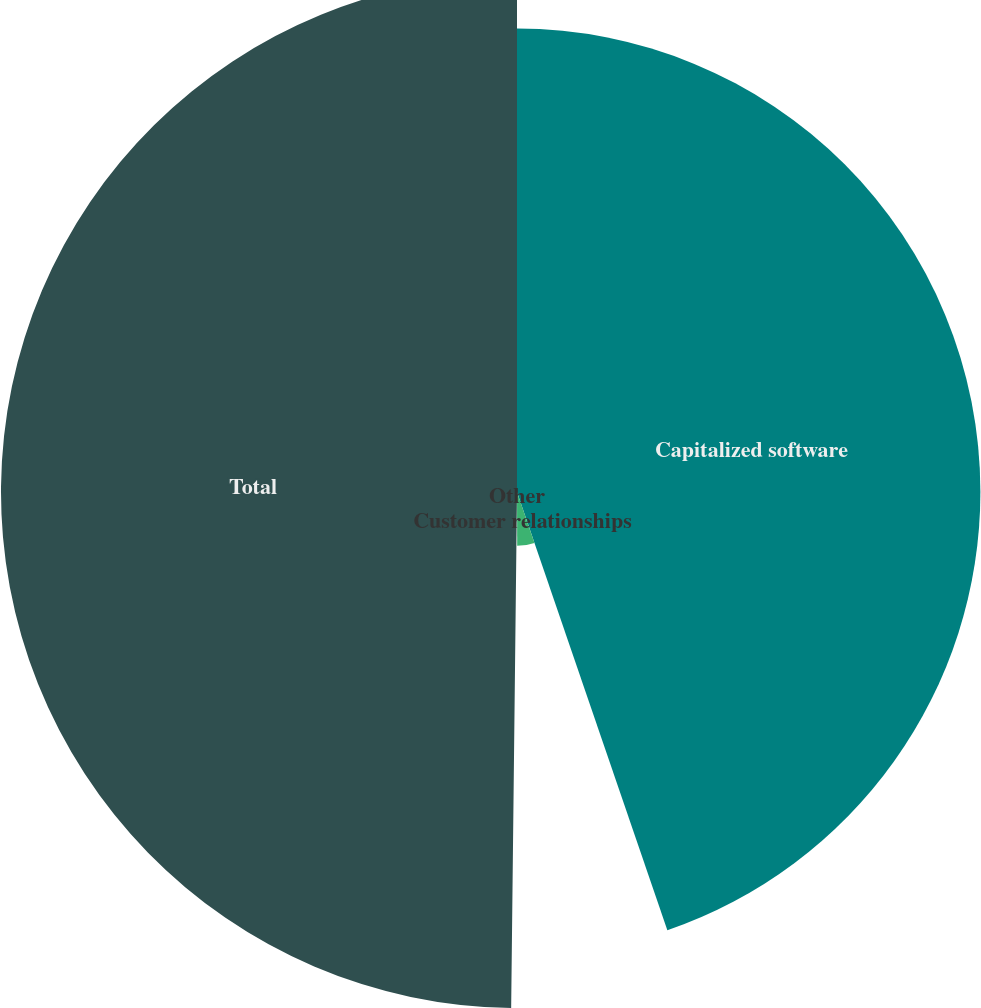Convert chart. <chart><loc_0><loc_0><loc_500><loc_500><pie_chart><fcel>Capitalized software<fcel>Customer relationships<fcel>Other<fcel>Total<nl><fcel>44.74%<fcel>5.2%<fcel>0.24%<fcel>49.82%<nl></chart> 